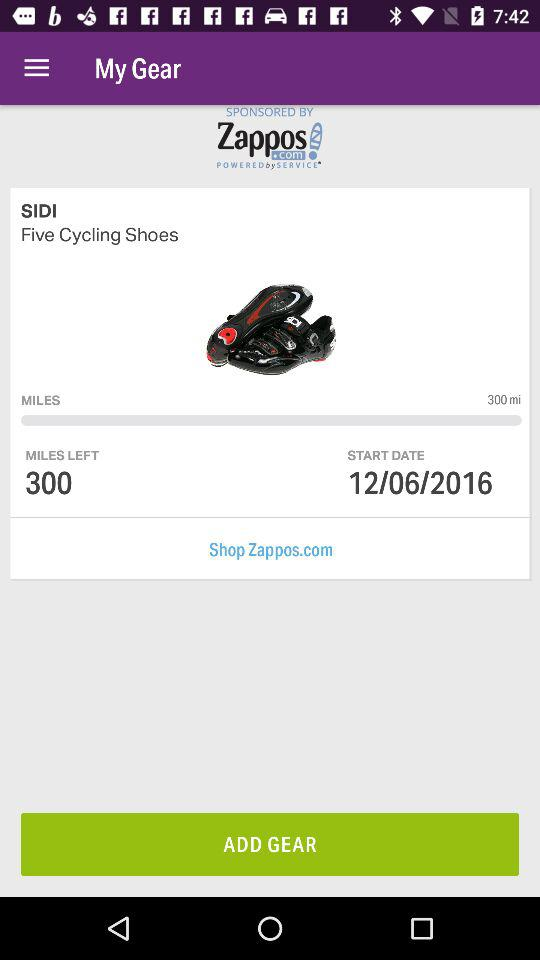How many miles do I have to complete to reach my goal?
Answer the question using a single word or phrase. 300 